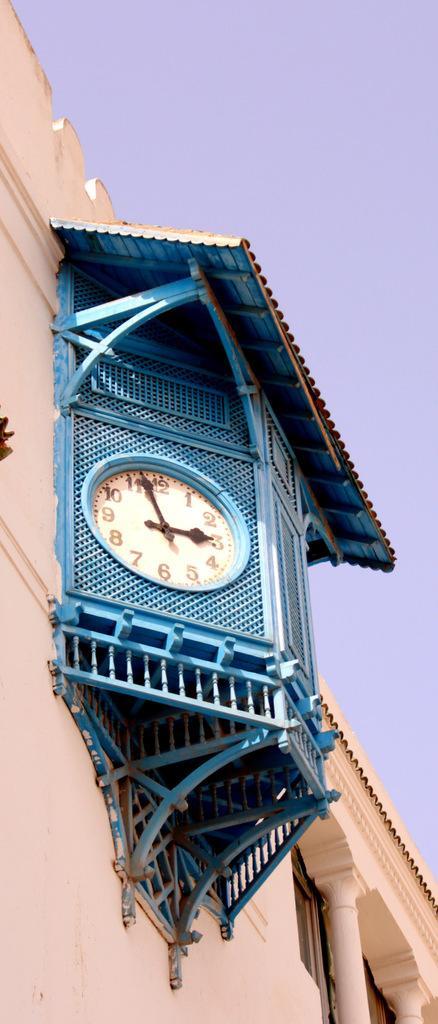Can you describe this image briefly? In this image I can see a building which is cream in color, a blue colored object to the building and a clock which is cream and black in color to the blue colored object. In the background I can see the sky. 